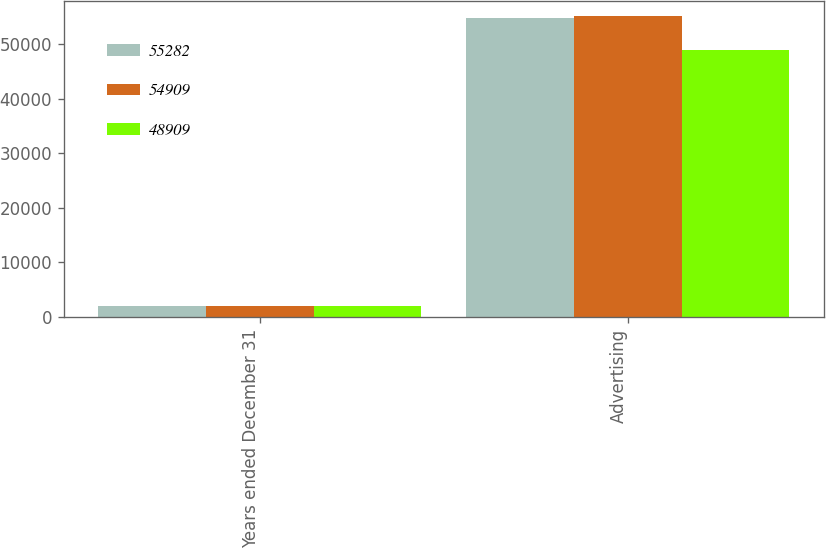<chart> <loc_0><loc_0><loc_500><loc_500><stacked_bar_chart><ecel><fcel>Years ended December 31<fcel>Advertising<nl><fcel>55282<fcel>2014<fcel>54909<nl><fcel>54909<fcel>2013<fcel>55282<nl><fcel>48909<fcel>2012<fcel>48909<nl></chart> 